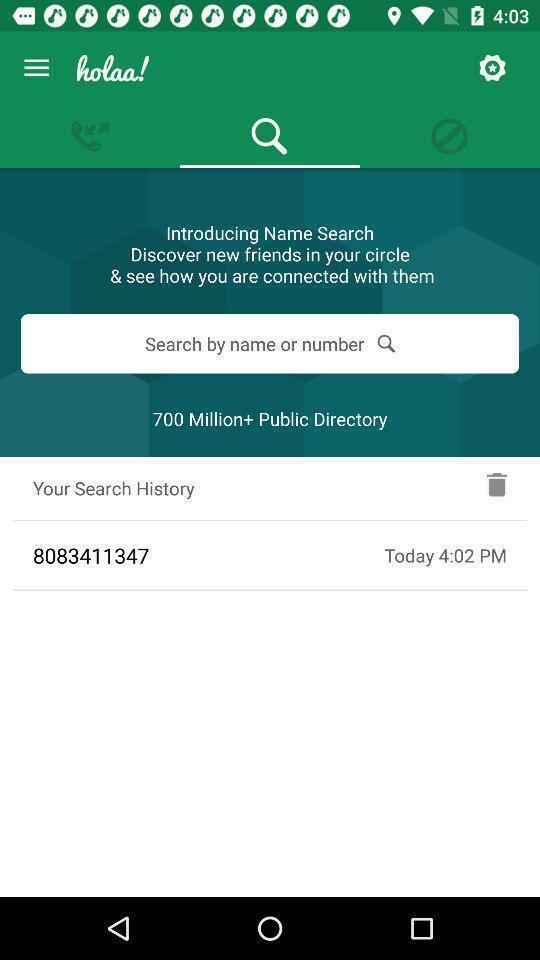Give me a narrative description of this picture. Screen displaying a search bar in a caller id application. 